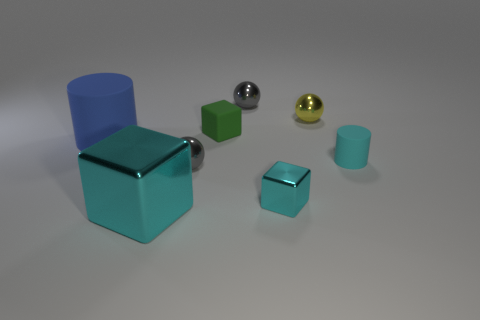How many small cubes are the same color as the big metallic thing?
Your response must be concise. 1. How many other objects are the same color as the big shiny object?
Give a very brief answer. 2. There is a small sphere that is in front of the cyan cylinder; is it the same color as the metal block that is to the right of the large metal cube?
Offer a very short reply. No. What material is the tiny cube behind the rubber cylinder that is left of the small cyan rubber cylinder on the right side of the large rubber object?
Offer a very short reply. Rubber. Are there any red metallic things that have the same size as the yellow metal ball?
Provide a succinct answer. No. What material is the cylinder that is the same size as the green matte object?
Offer a very short reply. Rubber. There is a gray metal thing to the right of the tiny green matte object; what is its shape?
Ensure brevity in your answer.  Sphere. Are the tiny sphere that is behind the yellow shiny thing and the big object that is behind the tiny cyan matte cylinder made of the same material?
Provide a short and direct response. No. What number of gray metal objects are the same shape as the tiny yellow metal object?
Give a very brief answer. 2. There is another block that is the same color as the large cube; what material is it?
Your answer should be compact. Metal. 